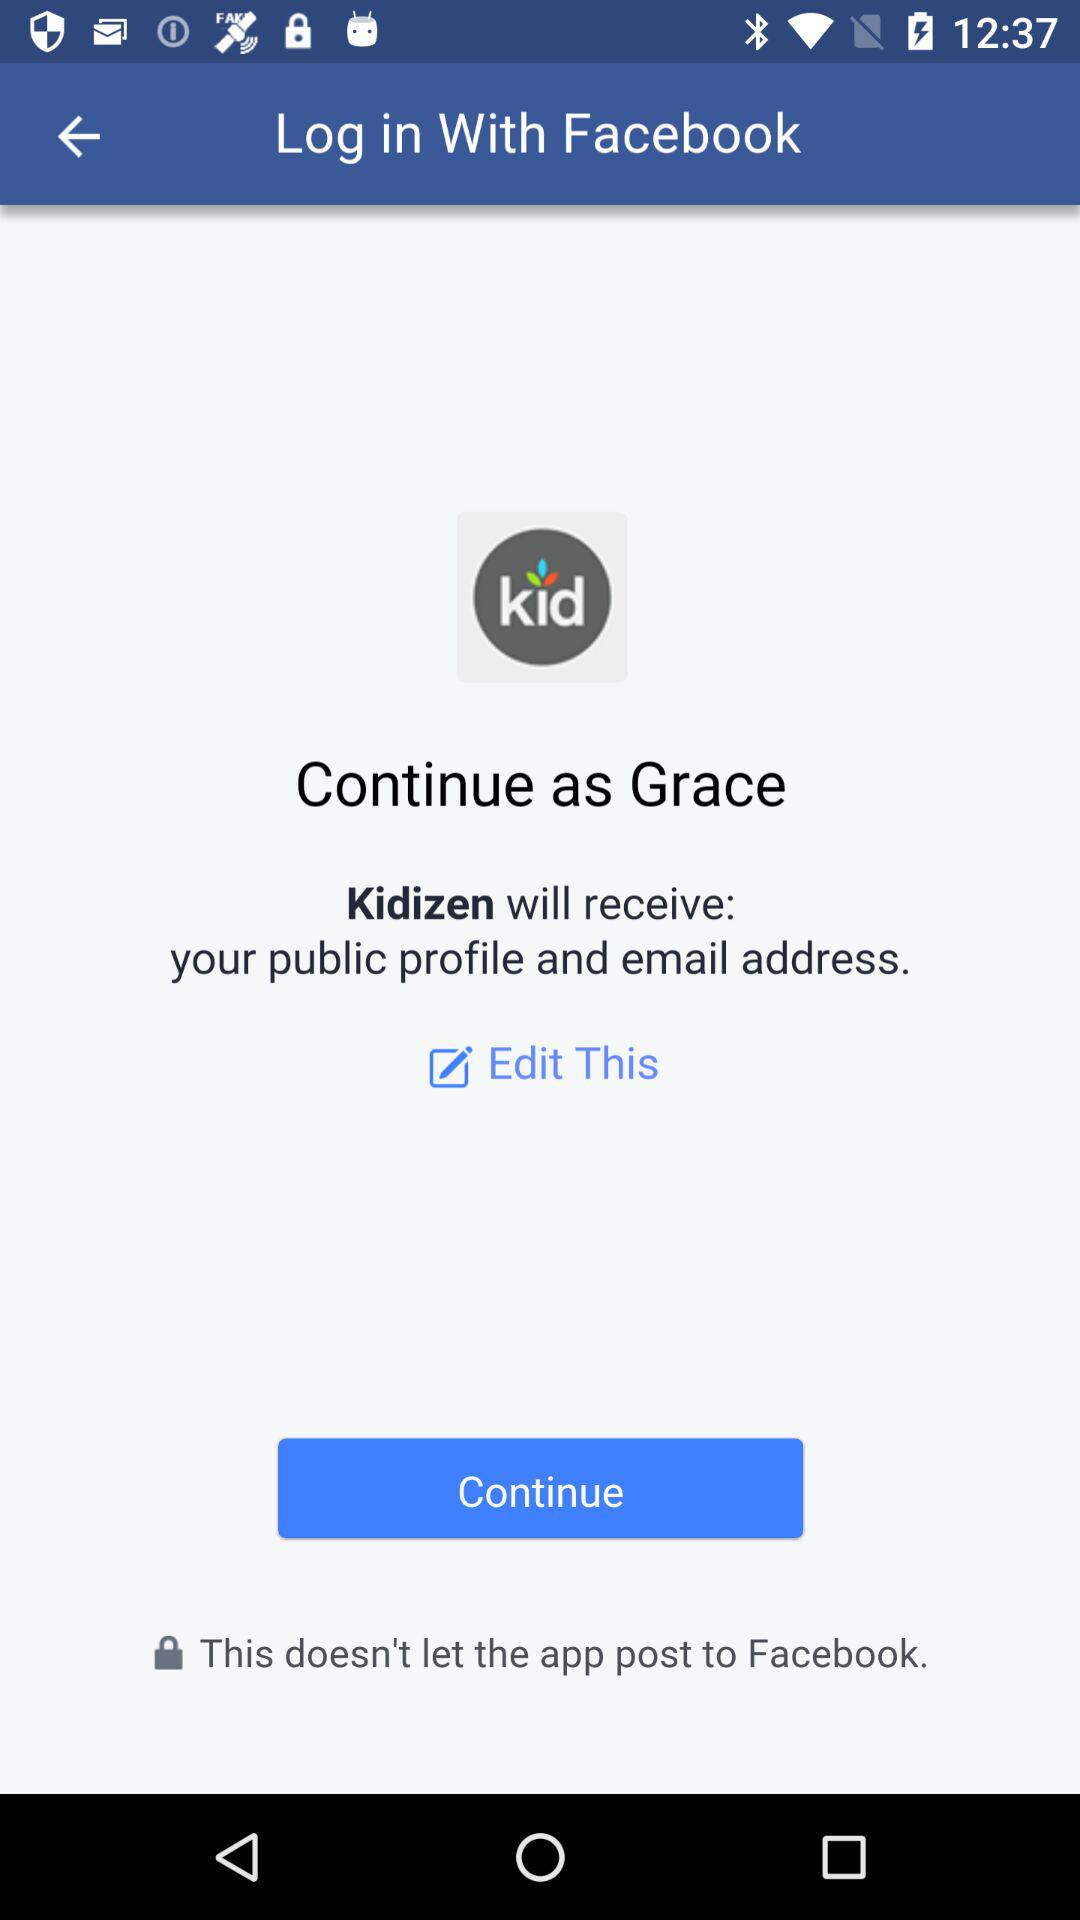What is the name of the user? The name of the user is Grace. 